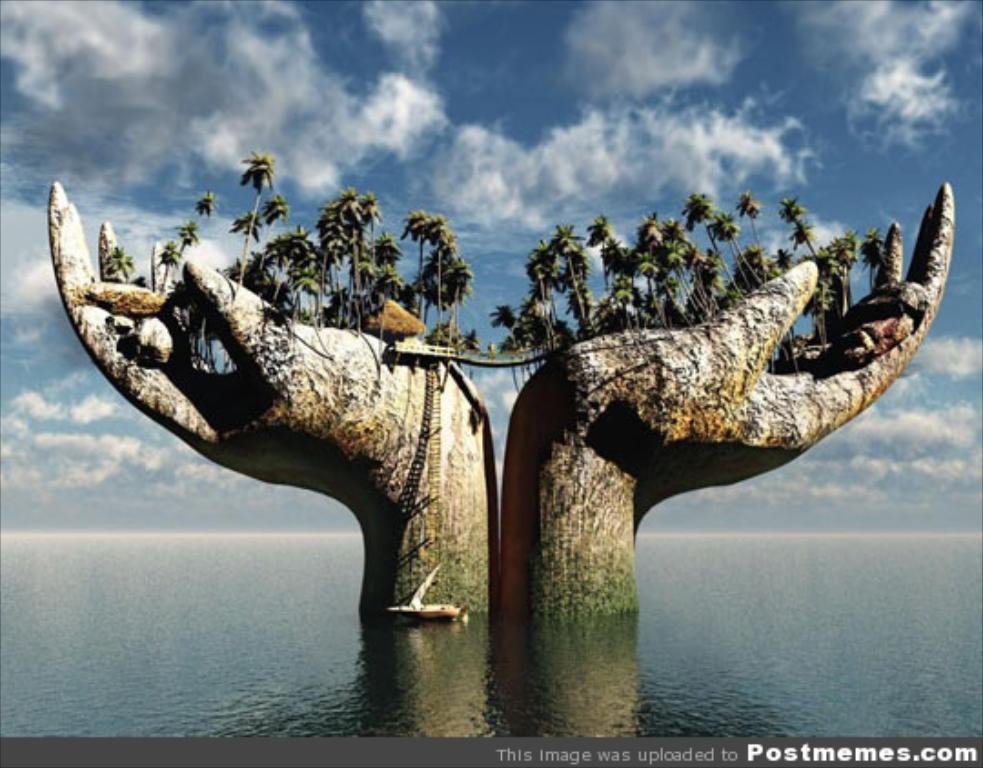Describe this image in one or two sentences. In the middle of the image, there is a bridge built between two statues of the hands, on which there are trees. These statues are in the water. Beside them, there is a boat on the water. On the bottom right, there is a watermark. 